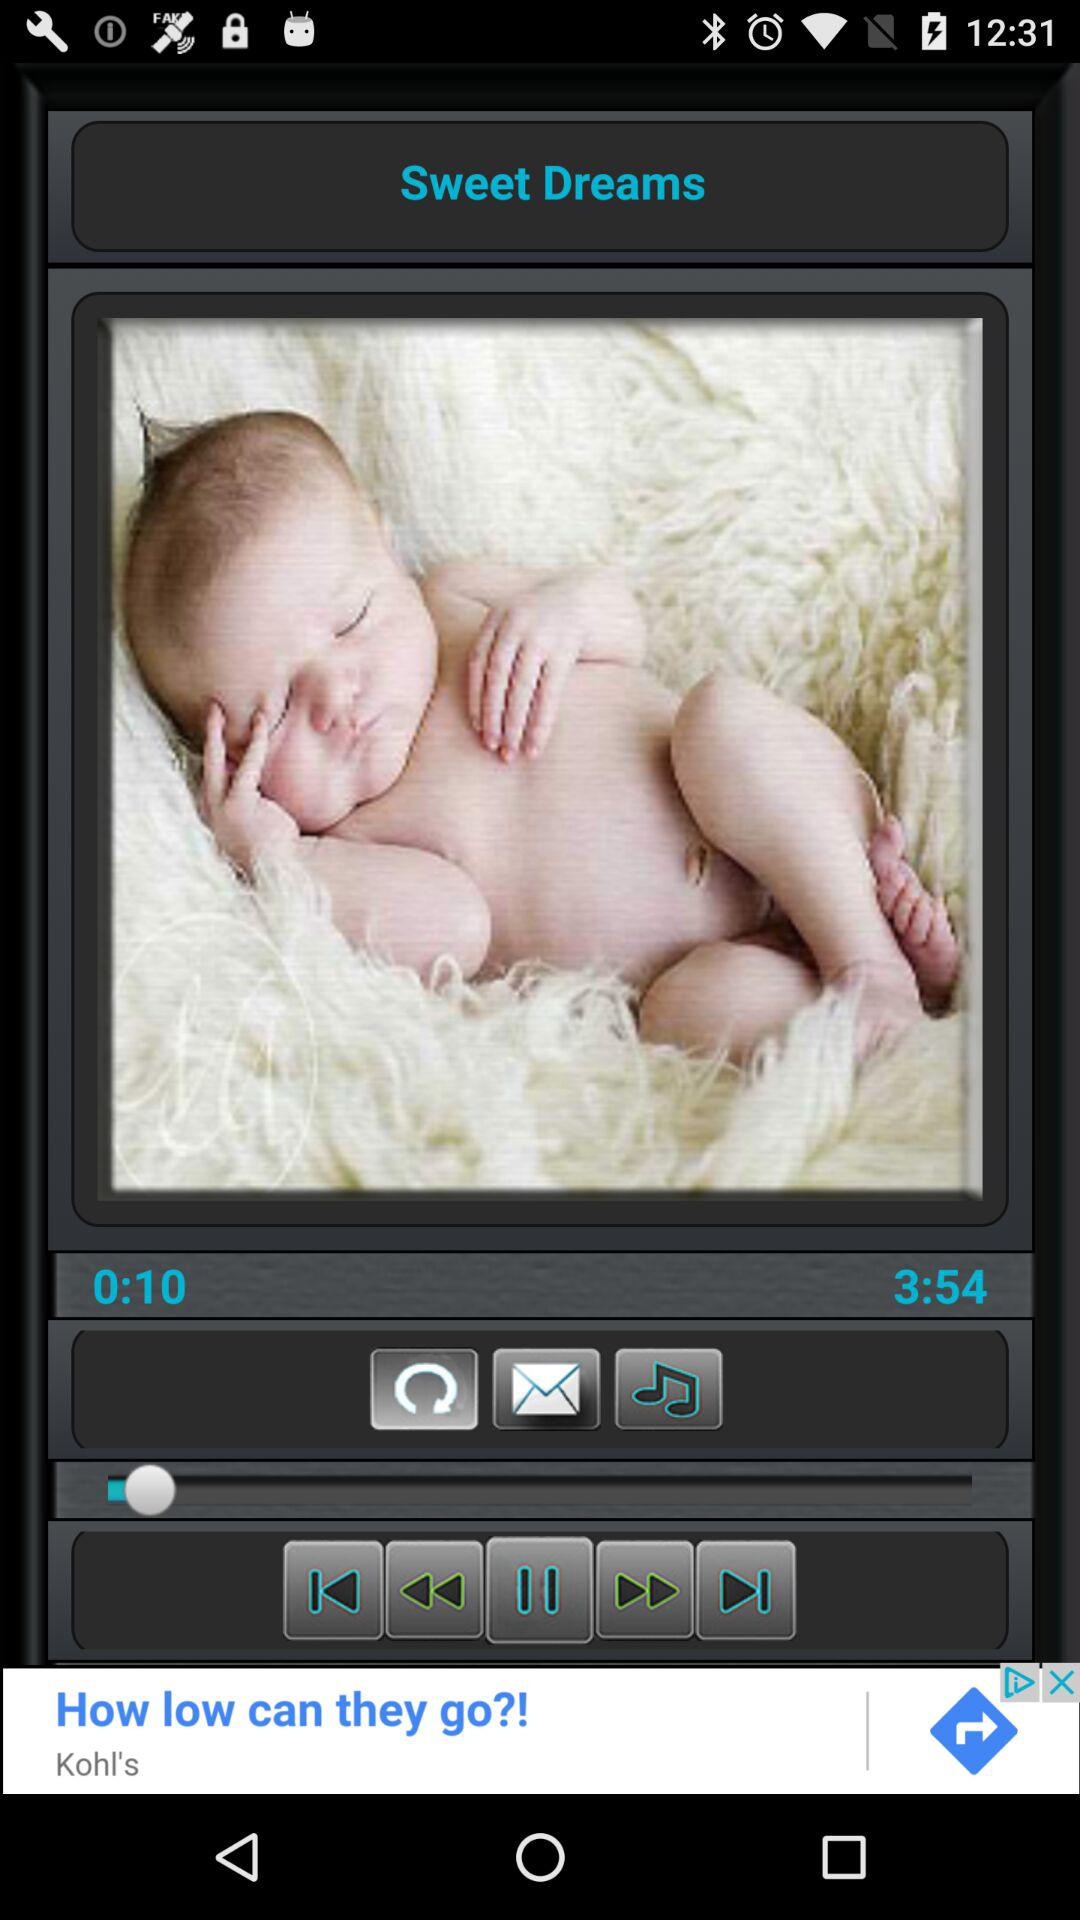For how long has the audio been played? The audio has been played for 10 seconds. 